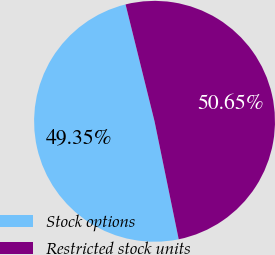<chart> <loc_0><loc_0><loc_500><loc_500><pie_chart><fcel>Stock options<fcel>Restricted stock units<nl><fcel>49.35%<fcel>50.65%<nl></chart> 